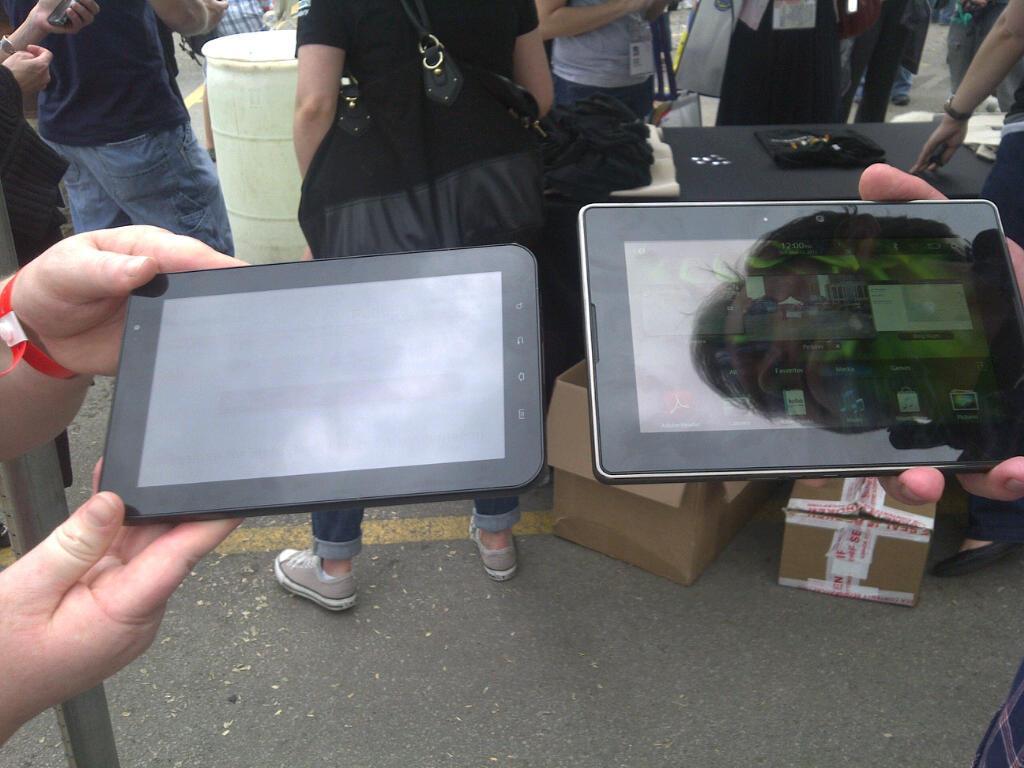Describe this image in one or two sentences. In this picture there are two persons holding a tab in their hands and there are few people,wooden boxes,a table and some other objects in the background. 